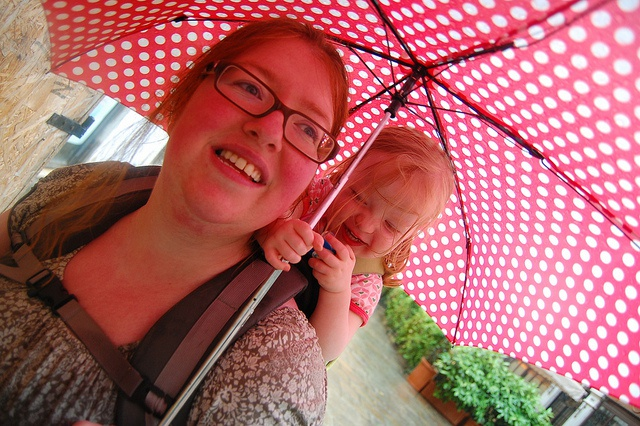Describe the objects in this image and their specific colors. I can see umbrella in tan, lightpink, white, and salmon tones, people in tan, maroon, brown, and black tones, people in tan, brown, salmon, and lightpink tones, backpack in tan, maroon, black, darkgray, and gray tones, and potted plant in tan, green, lightgreen, darkgreen, and brown tones in this image. 